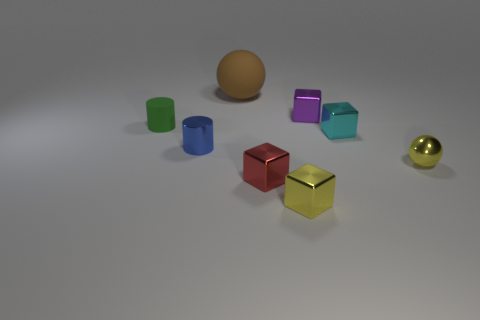What is the tiny object that is both in front of the purple metal object and behind the cyan block made of?
Your answer should be very brief. Rubber. Is the number of brown spheres less than the number of small purple metal cylinders?
Your answer should be compact. No. What size is the sphere that is on the right side of the ball behind the yellow sphere?
Your answer should be very brief. Small. What is the shape of the yellow object to the left of the tiny cube behind the rubber thing in front of the big brown object?
Offer a very short reply. Cube. The sphere that is the same material as the cyan object is what color?
Provide a short and direct response. Yellow. The tiny metal thing to the left of the large brown thing that is to the left of the tiny yellow metal object right of the tiny cyan shiny object is what color?
Provide a succinct answer. Blue. What number of cylinders are small things or tiny gray objects?
Keep it short and to the point. 2. There is a block that is the same color as the shiny ball; what material is it?
Provide a succinct answer. Metal. Does the tiny matte cylinder have the same color as the metal cube behind the tiny rubber cylinder?
Ensure brevity in your answer.  No. The tiny matte object is what color?
Offer a very short reply. Green. 